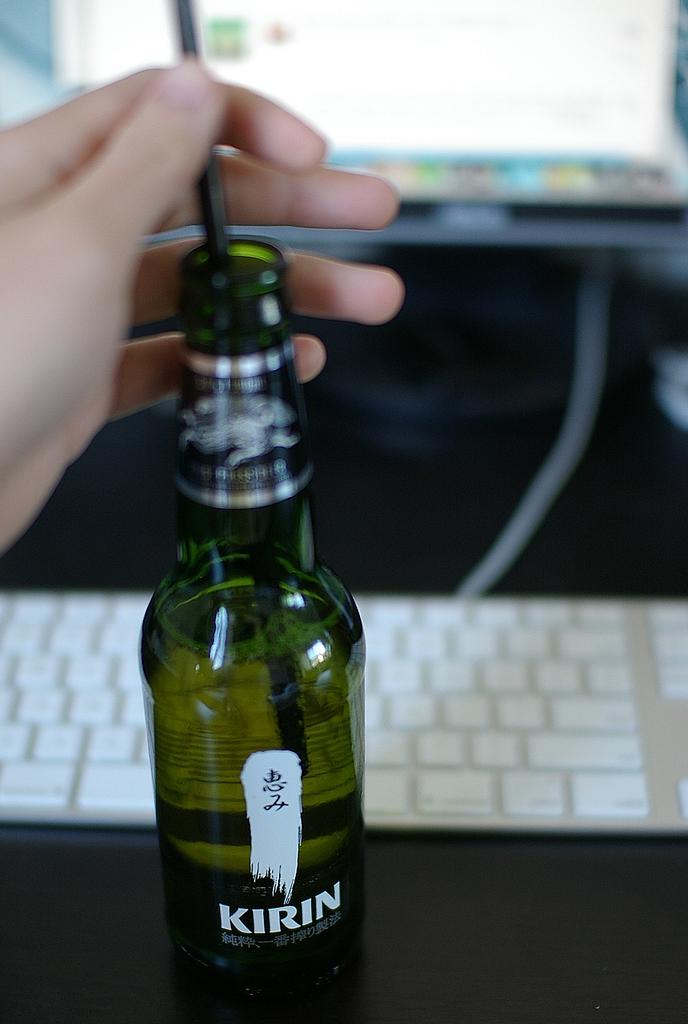What brand in this beer?
Ensure brevity in your answer.  Kirin. 